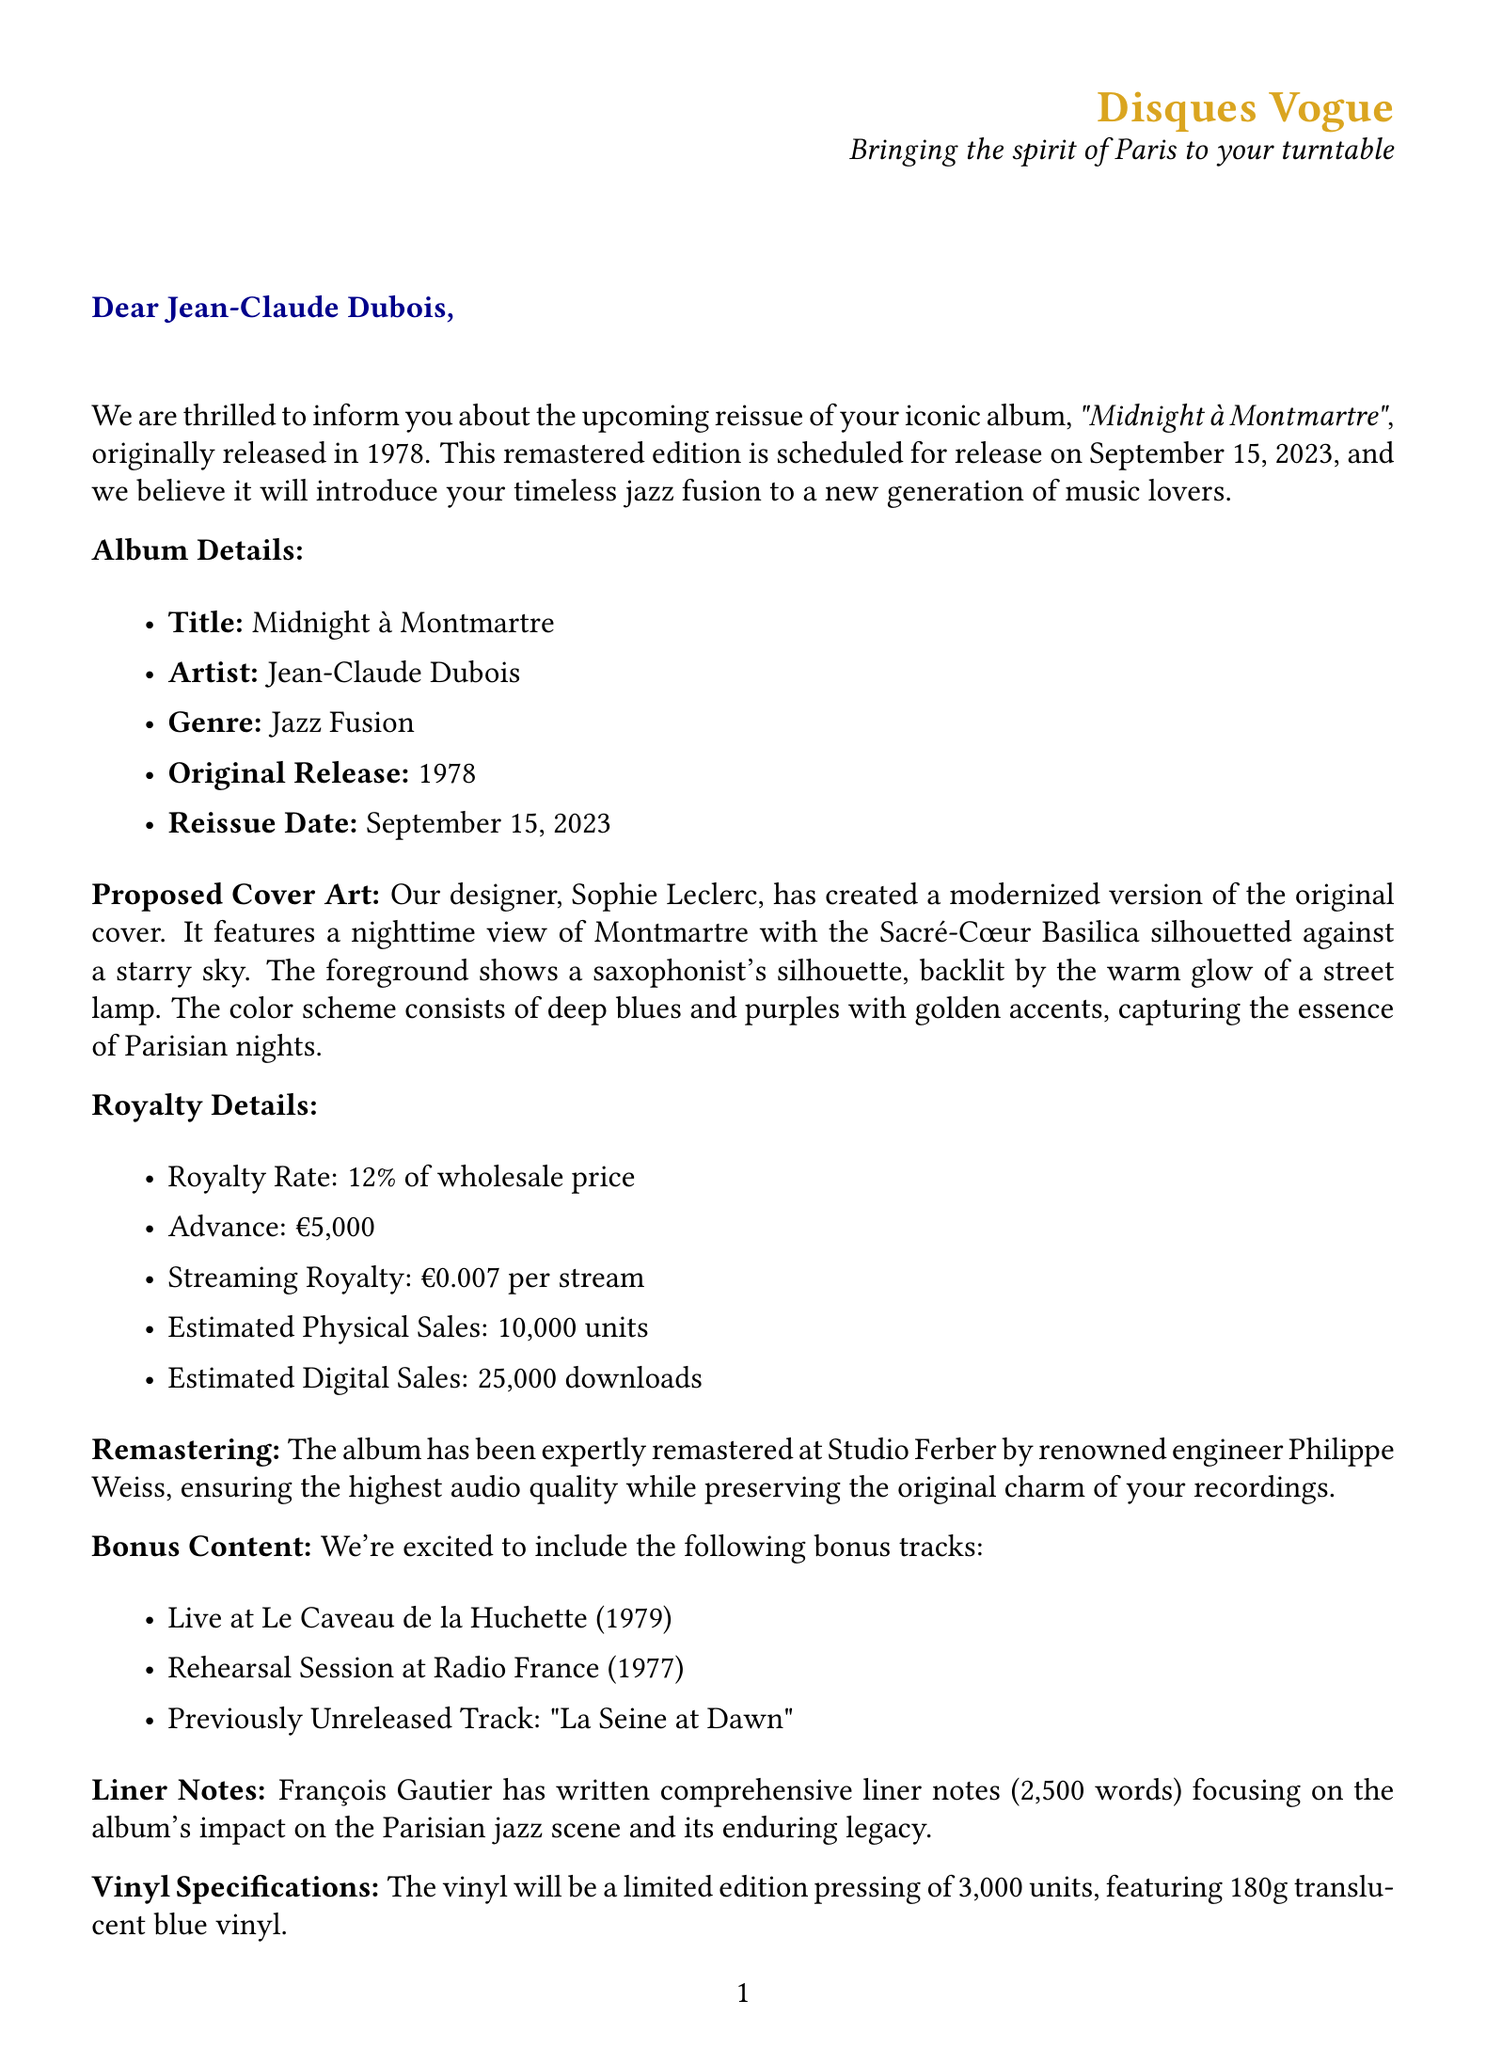What is the title of the album? The title is explicitly mentioned in the document as "Midnight à Montmartre."
Answer: Midnight à Montmartre Who is the artist of the album? The document states that the artist's name is Jean-Claude Dubois.
Answer: Jean-Claude Dubois What is the original release year of the album? The document indicates that the original release year is 1978.
Answer: 1978 What is the streaming royalty per stream? The document lists the streaming royalty as €0.007 per stream.
Answer: €0.007 per stream How many bonus tracks are included in the reissue? The number of bonus tracks listed in the document is three.
Answer: Three What is the total quantity of vinyl pressed for the reissue? The document specifies that the limited edition pressing is 3,000 units.
Answer: 3,000 Who wrote the liner notes for the album? The liner notes are authored by François Gautier according to the document.
Answer: François Gautier What date is the reissue scheduled for? The document confirms that the reissue release date is September 15, 2023.
Answer: September 15, 2023 What is the color of the vinyl for the reissue? The document describes the vinyl color as translucent blue.
Answer: Translucent blue 